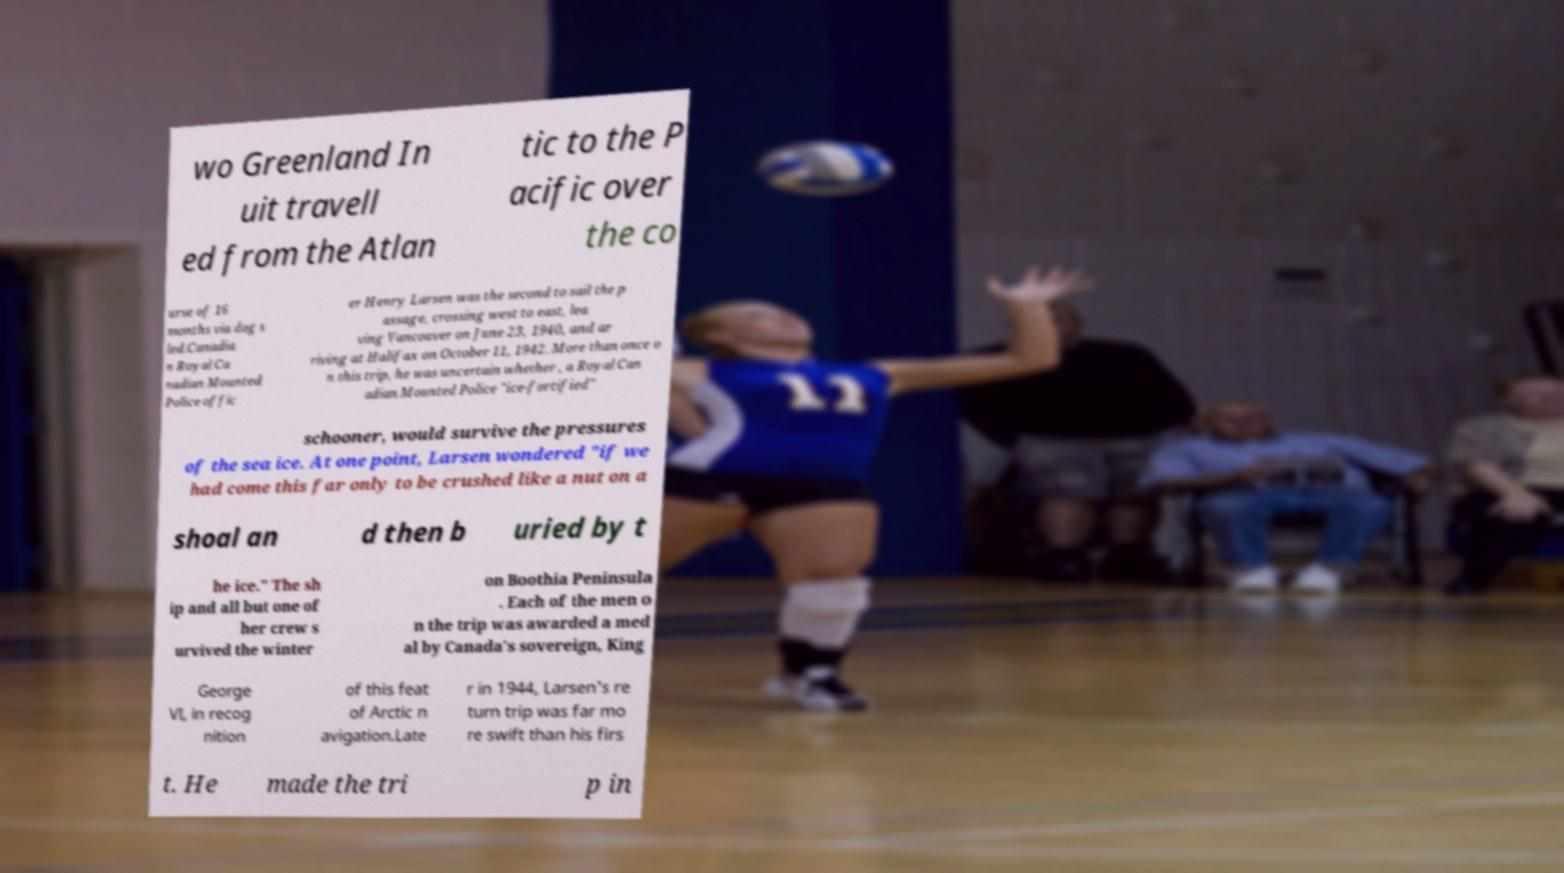Can you read and provide the text displayed in the image?This photo seems to have some interesting text. Can you extract and type it out for me? wo Greenland In uit travell ed from the Atlan tic to the P acific over the co urse of 16 months via dog s led.Canadia n Royal Ca nadian Mounted Police offic er Henry Larsen was the second to sail the p assage, crossing west to east, lea ving Vancouver on June 23, 1940, and ar riving at Halifax on October 11, 1942. More than once o n this trip, he was uncertain whether , a Royal Can adian Mounted Police "ice-fortified" schooner, would survive the pressures of the sea ice. At one point, Larsen wondered "if we had come this far only to be crushed like a nut on a shoal an d then b uried by t he ice." The sh ip and all but one of her crew s urvived the winter on Boothia Peninsula . Each of the men o n the trip was awarded a med al by Canada's sovereign, King George VI, in recog nition of this feat of Arctic n avigation.Late r in 1944, Larsen's re turn trip was far mo re swift than his firs t. He made the tri p in 